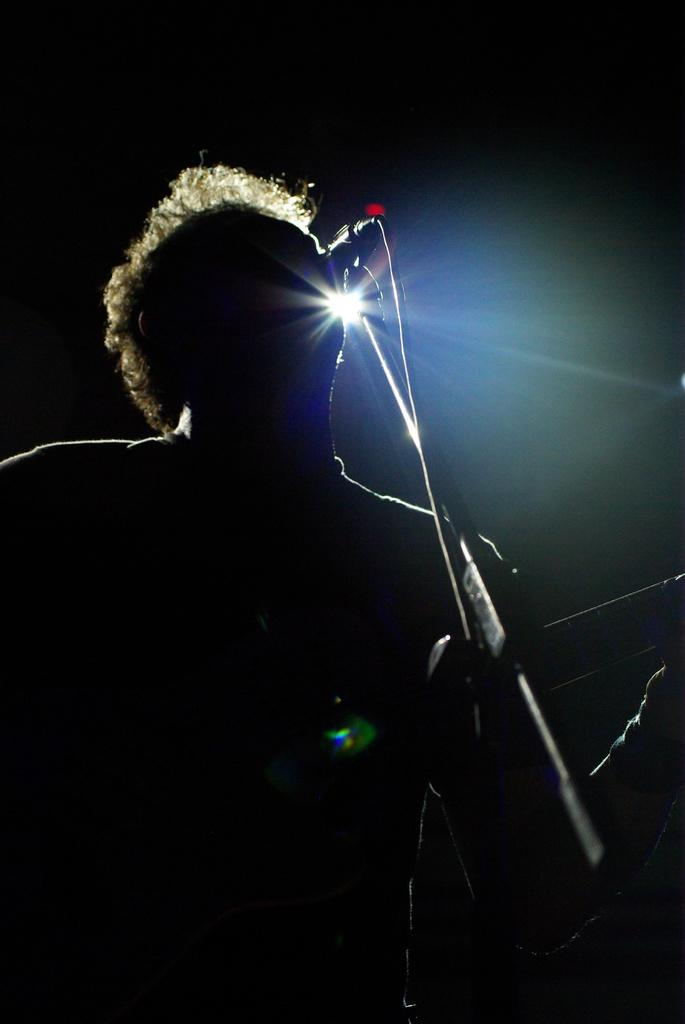What is the main subject of the image? There is a person in the image. What is the person doing in the image? The person is singing and playing a musical instrument. What is the color of the background in the image? The background of the image is black. How many geese can be seen in the image? There are no geese present in the image. 